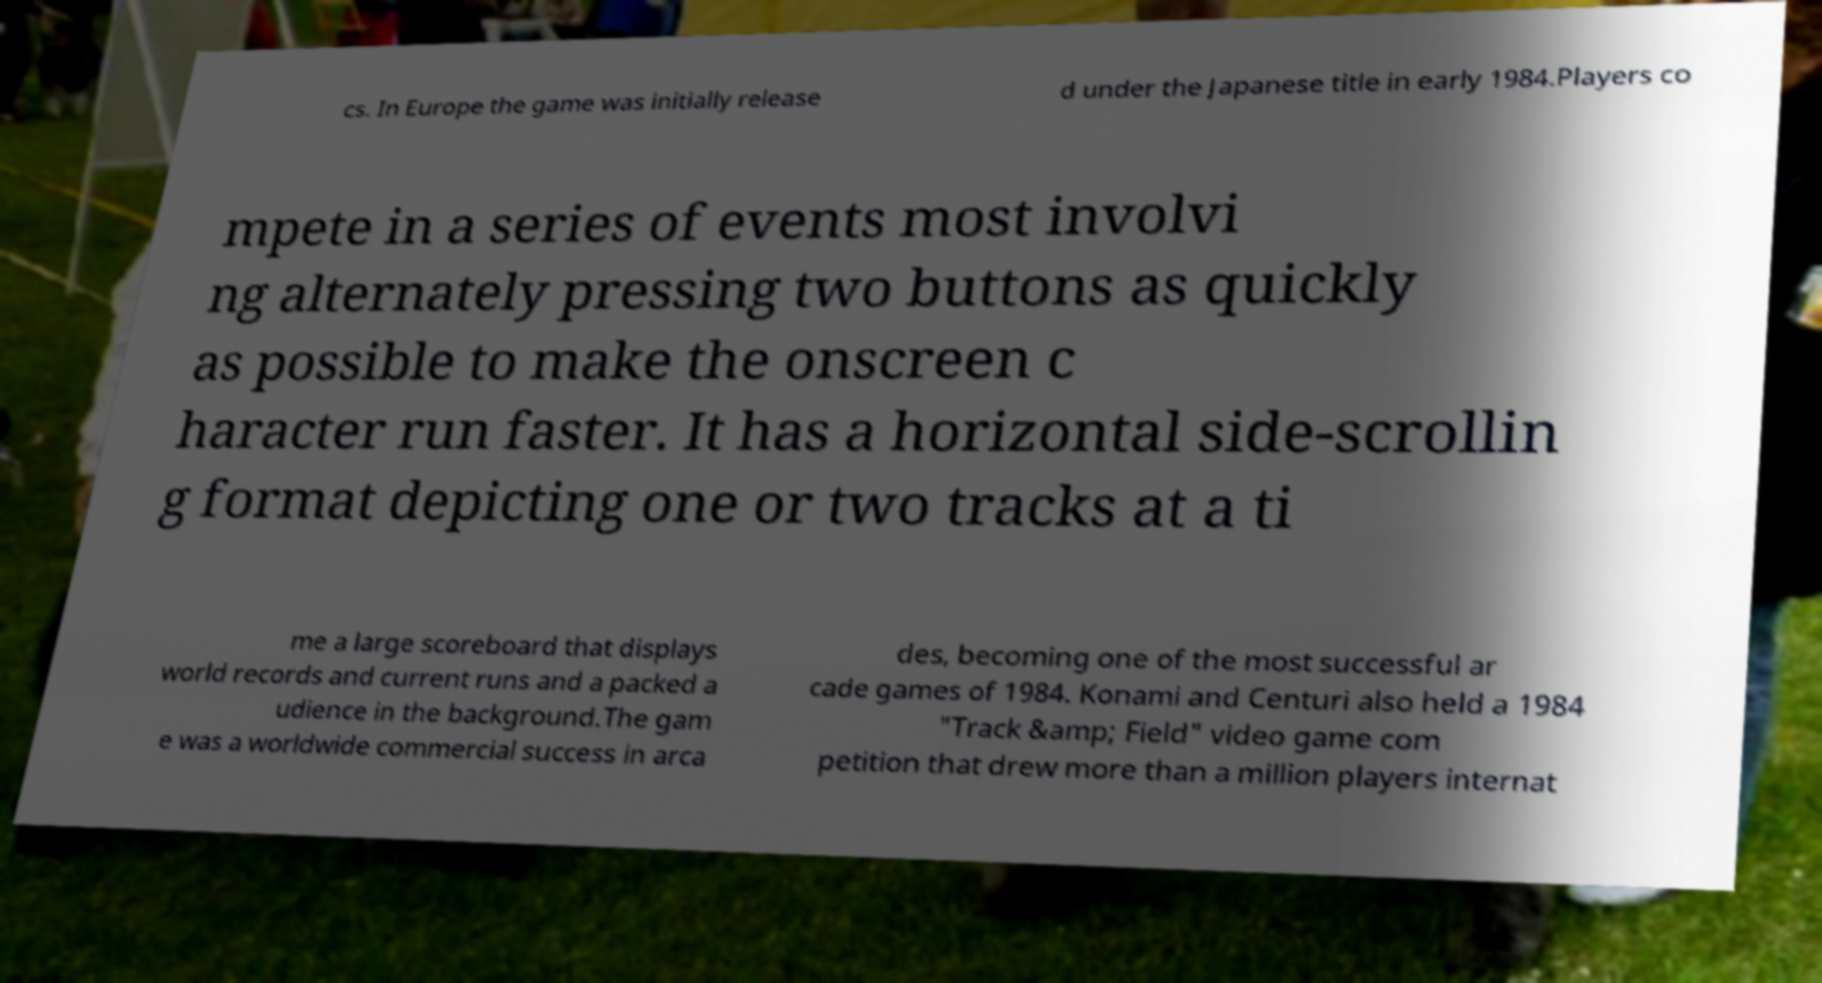Can you read and provide the text displayed in the image?This photo seems to have some interesting text. Can you extract and type it out for me? cs. In Europe the game was initially release d under the Japanese title in early 1984.Players co mpete in a series of events most involvi ng alternately pressing two buttons as quickly as possible to make the onscreen c haracter run faster. It has a horizontal side-scrollin g format depicting one or two tracks at a ti me a large scoreboard that displays world records and current runs and a packed a udience in the background.The gam e was a worldwide commercial success in arca des, becoming one of the most successful ar cade games of 1984. Konami and Centuri also held a 1984 "Track &amp; Field" video game com petition that drew more than a million players internat 